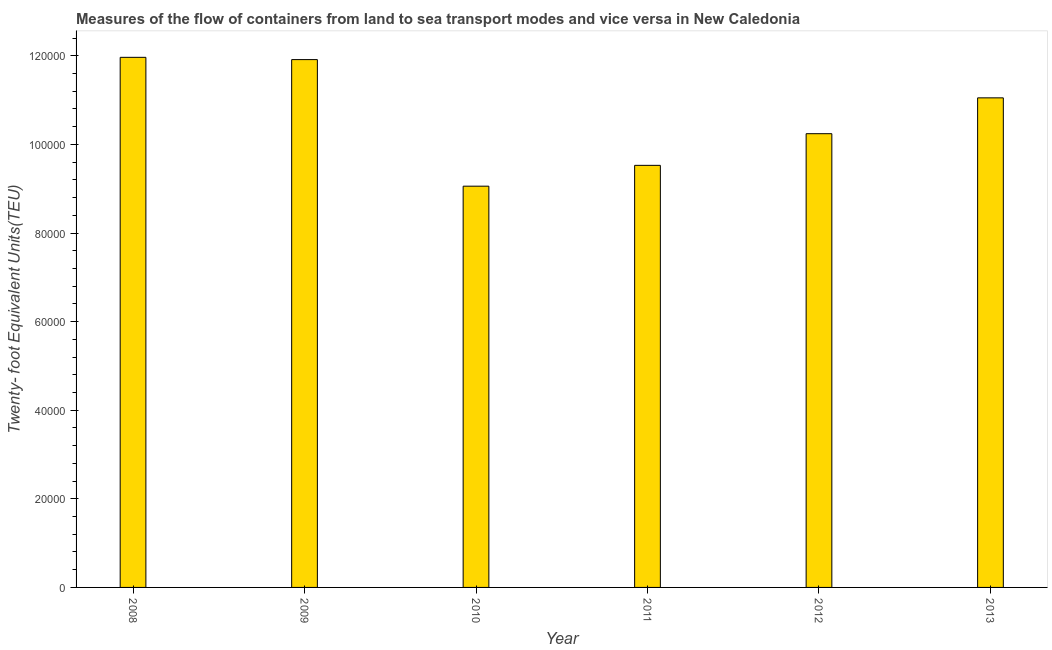Does the graph contain any zero values?
Your answer should be compact. No. Does the graph contain grids?
Ensure brevity in your answer.  No. What is the title of the graph?
Ensure brevity in your answer.  Measures of the flow of containers from land to sea transport modes and vice versa in New Caledonia. What is the label or title of the X-axis?
Ensure brevity in your answer.  Year. What is the label or title of the Y-axis?
Provide a succinct answer. Twenty- foot Equivalent Units(TEU). What is the container port traffic in 2013?
Provide a short and direct response. 1.11e+05. Across all years, what is the maximum container port traffic?
Offer a very short reply. 1.20e+05. Across all years, what is the minimum container port traffic?
Keep it short and to the point. 9.06e+04. In which year was the container port traffic maximum?
Your response must be concise. 2008. In which year was the container port traffic minimum?
Provide a short and direct response. 2010. What is the sum of the container port traffic?
Make the answer very short. 6.38e+05. What is the difference between the container port traffic in 2008 and 2009?
Make the answer very short. 514. What is the average container port traffic per year?
Your answer should be very brief. 1.06e+05. What is the median container port traffic?
Your answer should be very brief. 1.06e+05. In how many years, is the container port traffic greater than 20000 TEU?
Provide a short and direct response. 6. What is the ratio of the container port traffic in 2009 to that in 2011?
Your response must be concise. 1.25. Is the difference between the container port traffic in 2011 and 2013 greater than the difference between any two years?
Provide a succinct answer. No. What is the difference between the highest and the second highest container port traffic?
Provide a succinct answer. 514. Is the sum of the container port traffic in 2009 and 2010 greater than the maximum container port traffic across all years?
Give a very brief answer. Yes. What is the difference between the highest and the lowest container port traffic?
Make the answer very short. 2.91e+04. How many bars are there?
Your answer should be very brief. 6. How many years are there in the graph?
Your answer should be compact. 6. Are the values on the major ticks of Y-axis written in scientific E-notation?
Offer a very short reply. No. What is the Twenty- foot Equivalent Units(TEU) in 2008?
Your answer should be compact. 1.20e+05. What is the Twenty- foot Equivalent Units(TEU) of 2009?
Make the answer very short. 1.19e+05. What is the Twenty- foot Equivalent Units(TEU) of 2010?
Provide a short and direct response. 9.06e+04. What is the Twenty- foot Equivalent Units(TEU) in 2011?
Ensure brevity in your answer.  9.53e+04. What is the Twenty- foot Equivalent Units(TEU) in 2012?
Offer a very short reply. 1.02e+05. What is the Twenty- foot Equivalent Units(TEU) of 2013?
Keep it short and to the point. 1.11e+05. What is the difference between the Twenty- foot Equivalent Units(TEU) in 2008 and 2009?
Your answer should be very brief. 514. What is the difference between the Twenty- foot Equivalent Units(TEU) in 2008 and 2010?
Make the answer very short. 2.91e+04. What is the difference between the Twenty- foot Equivalent Units(TEU) in 2008 and 2011?
Your answer should be compact. 2.44e+04. What is the difference between the Twenty- foot Equivalent Units(TEU) in 2008 and 2012?
Give a very brief answer. 1.72e+04. What is the difference between the Twenty- foot Equivalent Units(TEU) in 2008 and 2013?
Make the answer very short. 9146.83. What is the difference between the Twenty- foot Equivalent Units(TEU) in 2009 and 2010?
Provide a short and direct response. 2.86e+04. What is the difference between the Twenty- foot Equivalent Units(TEU) in 2009 and 2011?
Your answer should be compact. 2.39e+04. What is the difference between the Twenty- foot Equivalent Units(TEU) in 2009 and 2012?
Provide a short and direct response. 1.67e+04. What is the difference between the Twenty- foot Equivalent Units(TEU) in 2009 and 2013?
Provide a short and direct response. 8632.83. What is the difference between the Twenty- foot Equivalent Units(TEU) in 2010 and 2011?
Offer a terse response. -4703. What is the difference between the Twenty- foot Equivalent Units(TEU) in 2010 and 2012?
Make the answer very short. -1.18e+04. What is the difference between the Twenty- foot Equivalent Units(TEU) in 2010 and 2013?
Make the answer very short. -1.99e+04. What is the difference between the Twenty- foot Equivalent Units(TEU) in 2011 and 2012?
Make the answer very short. -7145.77. What is the difference between the Twenty- foot Equivalent Units(TEU) in 2011 and 2013?
Offer a very short reply. -1.52e+04. What is the difference between the Twenty- foot Equivalent Units(TEU) in 2012 and 2013?
Your response must be concise. -8091.4. What is the ratio of the Twenty- foot Equivalent Units(TEU) in 2008 to that in 2009?
Provide a succinct answer. 1. What is the ratio of the Twenty- foot Equivalent Units(TEU) in 2008 to that in 2010?
Your answer should be compact. 1.32. What is the ratio of the Twenty- foot Equivalent Units(TEU) in 2008 to that in 2011?
Ensure brevity in your answer.  1.26. What is the ratio of the Twenty- foot Equivalent Units(TEU) in 2008 to that in 2012?
Provide a succinct answer. 1.17. What is the ratio of the Twenty- foot Equivalent Units(TEU) in 2008 to that in 2013?
Offer a very short reply. 1.08. What is the ratio of the Twenty- foot Equivalent Units(TEU) in 2009 to that in 2010?
Provide a succinct answer. 1.31. What is the ratio of the Twenty- foot Equivalent Units(TEU) in 2009 to that in 2011?
Ensure brevity in your answer.  1.25. What is the ratio of the Twenty- foot Equivalent Units(TEU) in 2009 to that in 2012?
Make the answer very short. 1.16. What is the ratio of the Twenty- foot Equivalent Units(TEU) in 2009 to that in 2013?
Make the answer very short. 1.08. What is the ratio of the Twenty- foot Equivalent Units(TEU) in 2010 to that in 2011?
Provide a succinct answer. 0.95. What is the ratio of the Twenty- foot Equivalent Units(TEU) in 2010 to that in 2012?
Your answer should be very brief. 0.88. What is the ratio of the Twenty- foot Equivalent Units(TEU) in 2010 to that in 2013?
Provide a succinct answer. 0.82. What is the ratio of the Twenty- foot Equivalent Units(TEU) in 2011 to that in 2013?
Ensure brevity in your answer.  0.86. What is the ratio of the Twenty- foot Equivalent Units(TEU) in 2012 to that in 2013?
Provide a succinct answer. 0.93. 